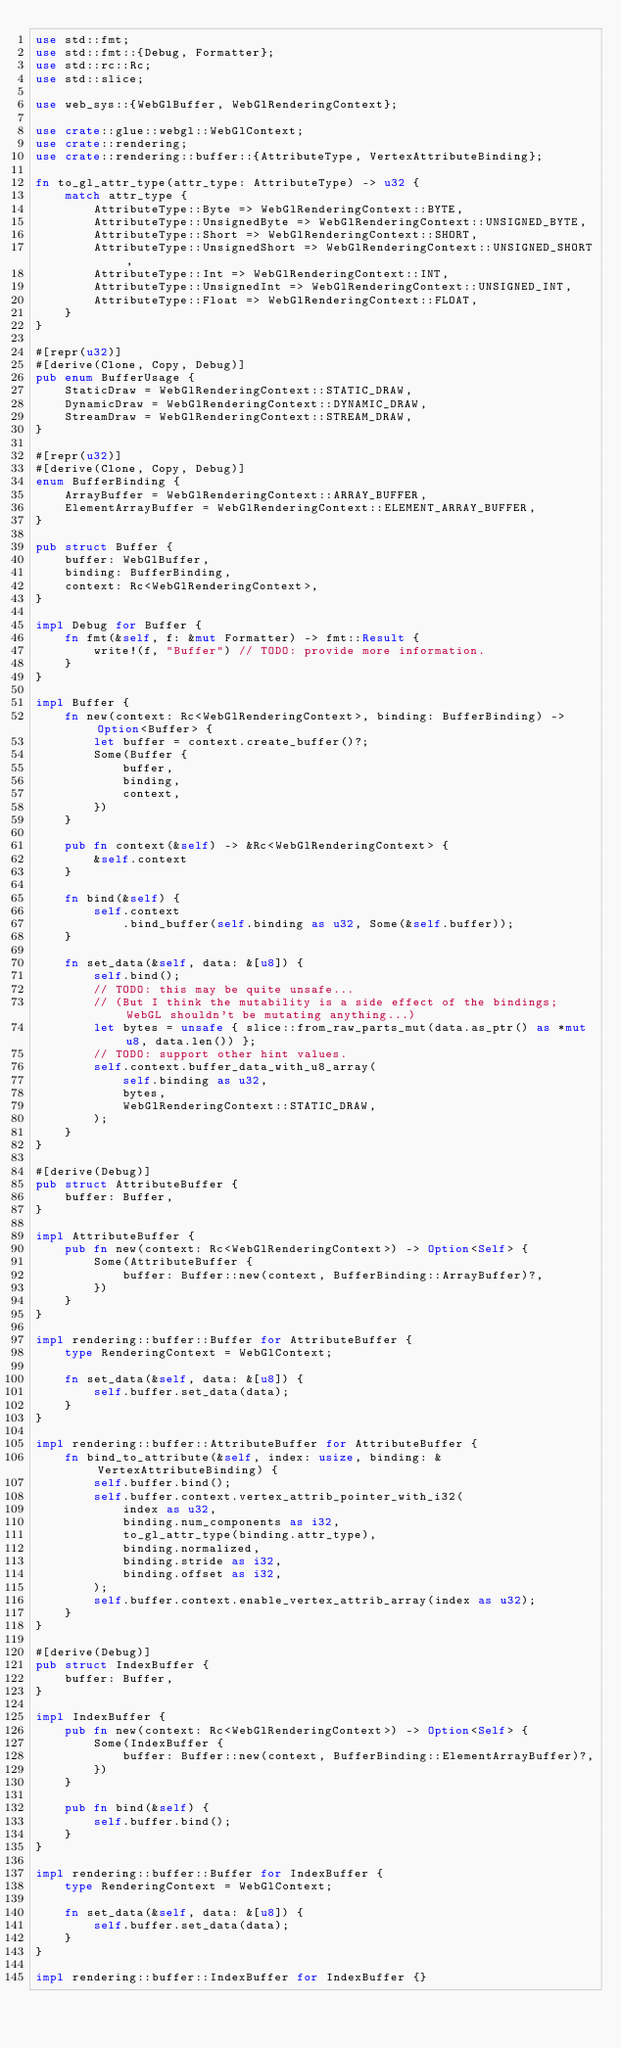Convert code to text. <code><loc_0><loc_0><loc_500><loc_500><_Rust_>use std::fmt;
use std::fmt::{Debug, Formatter};
use std::rc::Rc;
use std::slice;

use web_sys::{WebGlBuffer, WebGlRenderingContext};

use crate::glue::webgl::WebGlContext;
use crate::rendering;
use crate::rendering::buffer::{AttributeType, VertexAttributeBinding};

fn to_gl_attr_type(attr_type: AttributeType) -> u32 {
    match attr_type {
        AttributeType::Byte => WebGlRenderingContext::BYTE,
        AttributeType::UnsignedByte => WebGlRenderingContext::UNSIGNED_BYTE,
        AttributeType::Short => WebGlRenderingContext::SHORT,
        AttributeType::UnsignedShort => WebGlRenderingContext::UNSIGNED_SHORT,
        AttributeType::Int => WebGlRenderingContext::INT,
        AttributeType::UnsignedInt => WebGlRenderingContext::UNSIGNED_INT,
        AttributeType::Float => WebGlRenderingContext::FLOAT,
    }
}

#[repr(u32)]
#[derive(Clone, Copy, Debug)]
pub enum BufferUsage {
    StaticDraw = WebGlRenderingContext::STATIC_DRAW,
    DynamicDraw = WebGlRenderingContext::DYNAMIC_DRAW,
    StreamDraw = WebGlRenderingContext::STREAM_DRAW,
}

#[repr(u32)]
#[derive(Clone, Copy, Debug)]
enum BufferBinding {
    ArrayBuffer = WebGlRenderingContext::ARRAY_BUFFER,
    ElementArrayBuffer = WebGlRenderingContext::ELEMENT_ARRAY_BUFFER,
}

pub struct Buffer {
    buffer: WebGlBuffer,
    binding: BufferBinding,
    context: Rc<WebGlRenderingContext>,
}

impl Debug for Buffer {
    fn fmt(&self, f: &mut Formatter) -> fmt::Result {
        write!(f, "Buffer") // TODO: provide more information.
    }
}

impl Buffer {
    fn new(context: Rc<WebGlRenderingContext>, binding: BufferBinding) -> Option<Buffer> {
        let buffer = context.create_buffer()?;
        Some(Buffer {
            buffer,
            binding,
            context,
        })
    }

    pub fn context(&self) -> &Rc<WebGlRenderingContext> {
        &self.context
    }

    fn bind(&self) {
        self.context
            .bind_buffer(self.binding as u32, Some(&self.buffer));
    }

    fn set_data(&self, data: &[u8]) {
        self.bind();
        // TODO: this may be quite unsafe...
        // (But I think the mutability is a side effect of the bindings; WebGL shouldn't be mutating anything...)
        let bytes = unsafe { slice::from_raw_parts_mut(data.as_ptr() as *mut u8, data.len()) };
        // TODO: support other hint values.
        self.context.buffer_data_with_u8_array(
            self.binding as u32,
            bytes,
            WebGlRenderingContext::STATIC_DRAW,
        );
    }
}

#[derive(Debug)]
pub struct AttributeBuffer {
    buffer: Buffer,
}

impl AttributeBuffer {
    pub fn new(context: Rc<WebGlRenderingContext>) -> Option<Self> {
        Some(AttributeBuffer {
            buffer: Buffer::new(context, BufferBinding::ArrayBuffer)?,
        })
    }
}

impl rendering::buffer::Buffer for AttributeBuffer {
    type RenderingContext = WebGlContext;

    fn set_data(&self, data: &[u8]) {
        self.buffer.set_data(data);
    }
}

impl rendering::buffer::AttributeBuffer for AttributeBuffer {
    fn bind_to_attribute(&self, index: usize, binding: &VertexAttributeBinding) {
        self.buffer.bind();
        self.buffer.context.vertex_attrib_pointer_with_i32(
            index as u32,
            binding.num_components as i32,
            to_gl_attr_type(binding.attr_type),
            binding.normalized,
            binding.stride as i32,
            binding.offset as i32,
        );
        self.buffer.context.enable_vertex_attrib_array(index as u32);
    }
}

#[derive(Debug)]
pub struct IndexBuffer {
    buffer: Buffer,
}

impl IndexBuffer {
    pub fn new(context: Rc<WebGlRenderingContext>) -> Option<Self> {
        Some(IndexBuffer {
            buffer: Buffer::new(context, BufferBinding::ElementArrayBuffer)?,
        })
    }

    pub fn bind(&self) {
        self.buffer.bind();
    }
}

impl rendering::buffer::Buffer for IndexBuffer {
    type RenderingContext = WebGlContext;

    fn set_data(&self, data: &[u8]) {
        self.buffer.set_data(data);
    }
}

impl rendering::buffer::IndexBuffer for IndexBuffer {}
</code> 